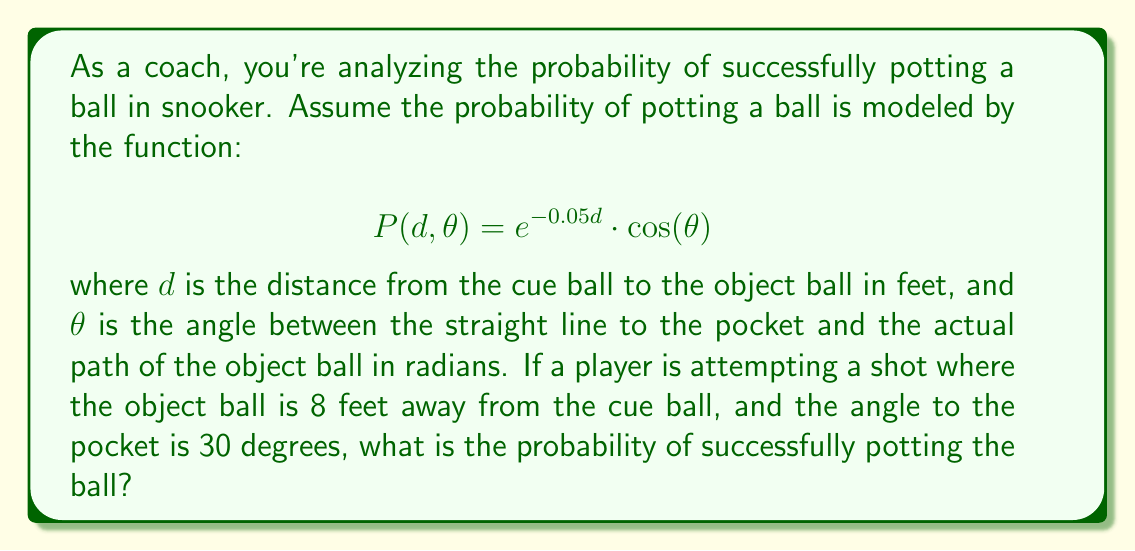Can you solve this math problem? Let's approach this step-by-step:

1) We are given the probability function:
   $$P(d, \theta) = e^{-0.05d} \cdot \cos(\theta)$$

2) We know that:
   - The distance $d = 8$ feet
   - The angle $\theta = 30$ degrees

3) First, we need to convert the angle from degrees to radians:
   $$30° = \frac{30 \pi}{180} = \frac{\pi}{6} \approx 0.5236 \text{ radians}$$

4) Now we can substitute these values into our probability function:
   $$P(8, \frac{\pi}{6}) = e^{-0.05 \cdot 8} \cdot \cos(\frac{\pi}{6})$$

5) Let's calculate each part separately:
   - $e^{-0.05 \cdot 8} = e^{-0.4} \approx 0.6703$
   - $\cos(\frac{\pi}{6}) = \frac{\sqrt{3}}{2} \approx 0.8660$

6) Multiplying these together:
   $$P(8, \frac{\pi}{6}) = 0.6703 \cdot 0.8660 \approx 0.5805$$

7) Therefore, the probability of successfully potting the ball is approximately 0.5805 or 58.05%.
Answer: 0.5805 